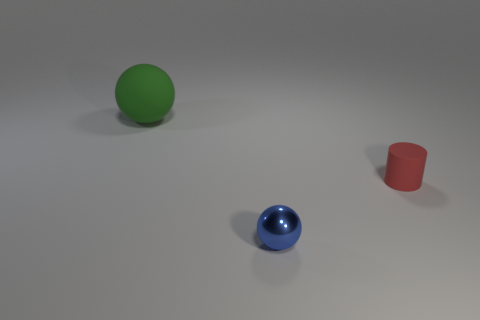What material is the blue thing?
Offer a terse response. Metal. What is the material of the ball that is in front of the matte thing that is to the left of the matte thing right of the big object?
Give a very brief answer. Metal. Is there any other thing that is the same shape as the tiny red matte object?
Make the answer very short. No. There is another thing that is the same shape as the tiny blue object; what is its color?
Your answer should be very brief. Green. Is the number of small objects that are left of the red cylinder greater than the number of large cylinders?
Make the answer very short. Yes. How many other objects are there of the same size as the green matte ball?
Keep it short and to the point. 0. How many things are both in front of the cylinder and left of the tiny metallic object?
Provide a short and direct response. 0. Does the object behind the tiny red matte cylinder have the same material as the small cylinder?
Your answer should be compact. Yes. What shape is the matte object that is in front of the object behind the object on the right side of the tiny shiny sphere?
Your response must be concise. Cylinder. Are there an equal number of matte objects on the right side of the large ball and large green matte things in front of the tiny metallic object?
Your answer should be compact. No. 